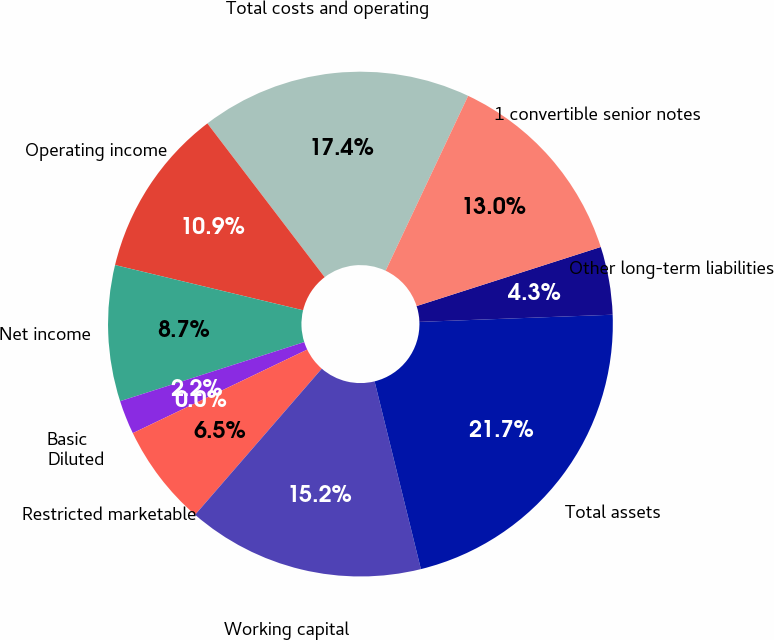Convert chart. <chart><loc_0><loc_0><loc_500><loc_500><pie_chart><fcel>Total costs and operating<fcel>Operating income<fcel>Net income<fcel>Basic<fcel>Diluted<fcel>Restricted marketable<fcel>Working capital<fcel>Total assets<fcel>Other long-term liabilities<fcel>1 convertible senior notes<nl><fcel>17.39%<fcel>10.87%<fcel>8.7%<fcel>2.17%<fcel>0.0%<fcel>6.52%<fcel>15.22%<fcel>21.74%<fcel>4.35%<fcel>13.04%<nl></chart> 